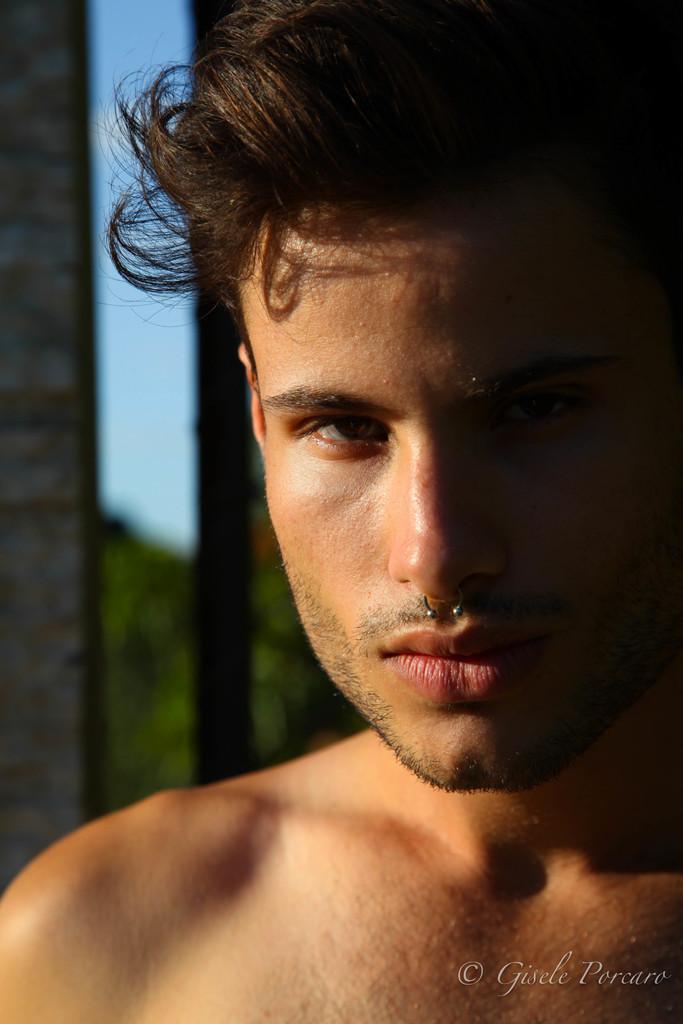Please provide a concise description of this image. In this image we can see a person, and the background is blurred, also we can see the text on the image. 